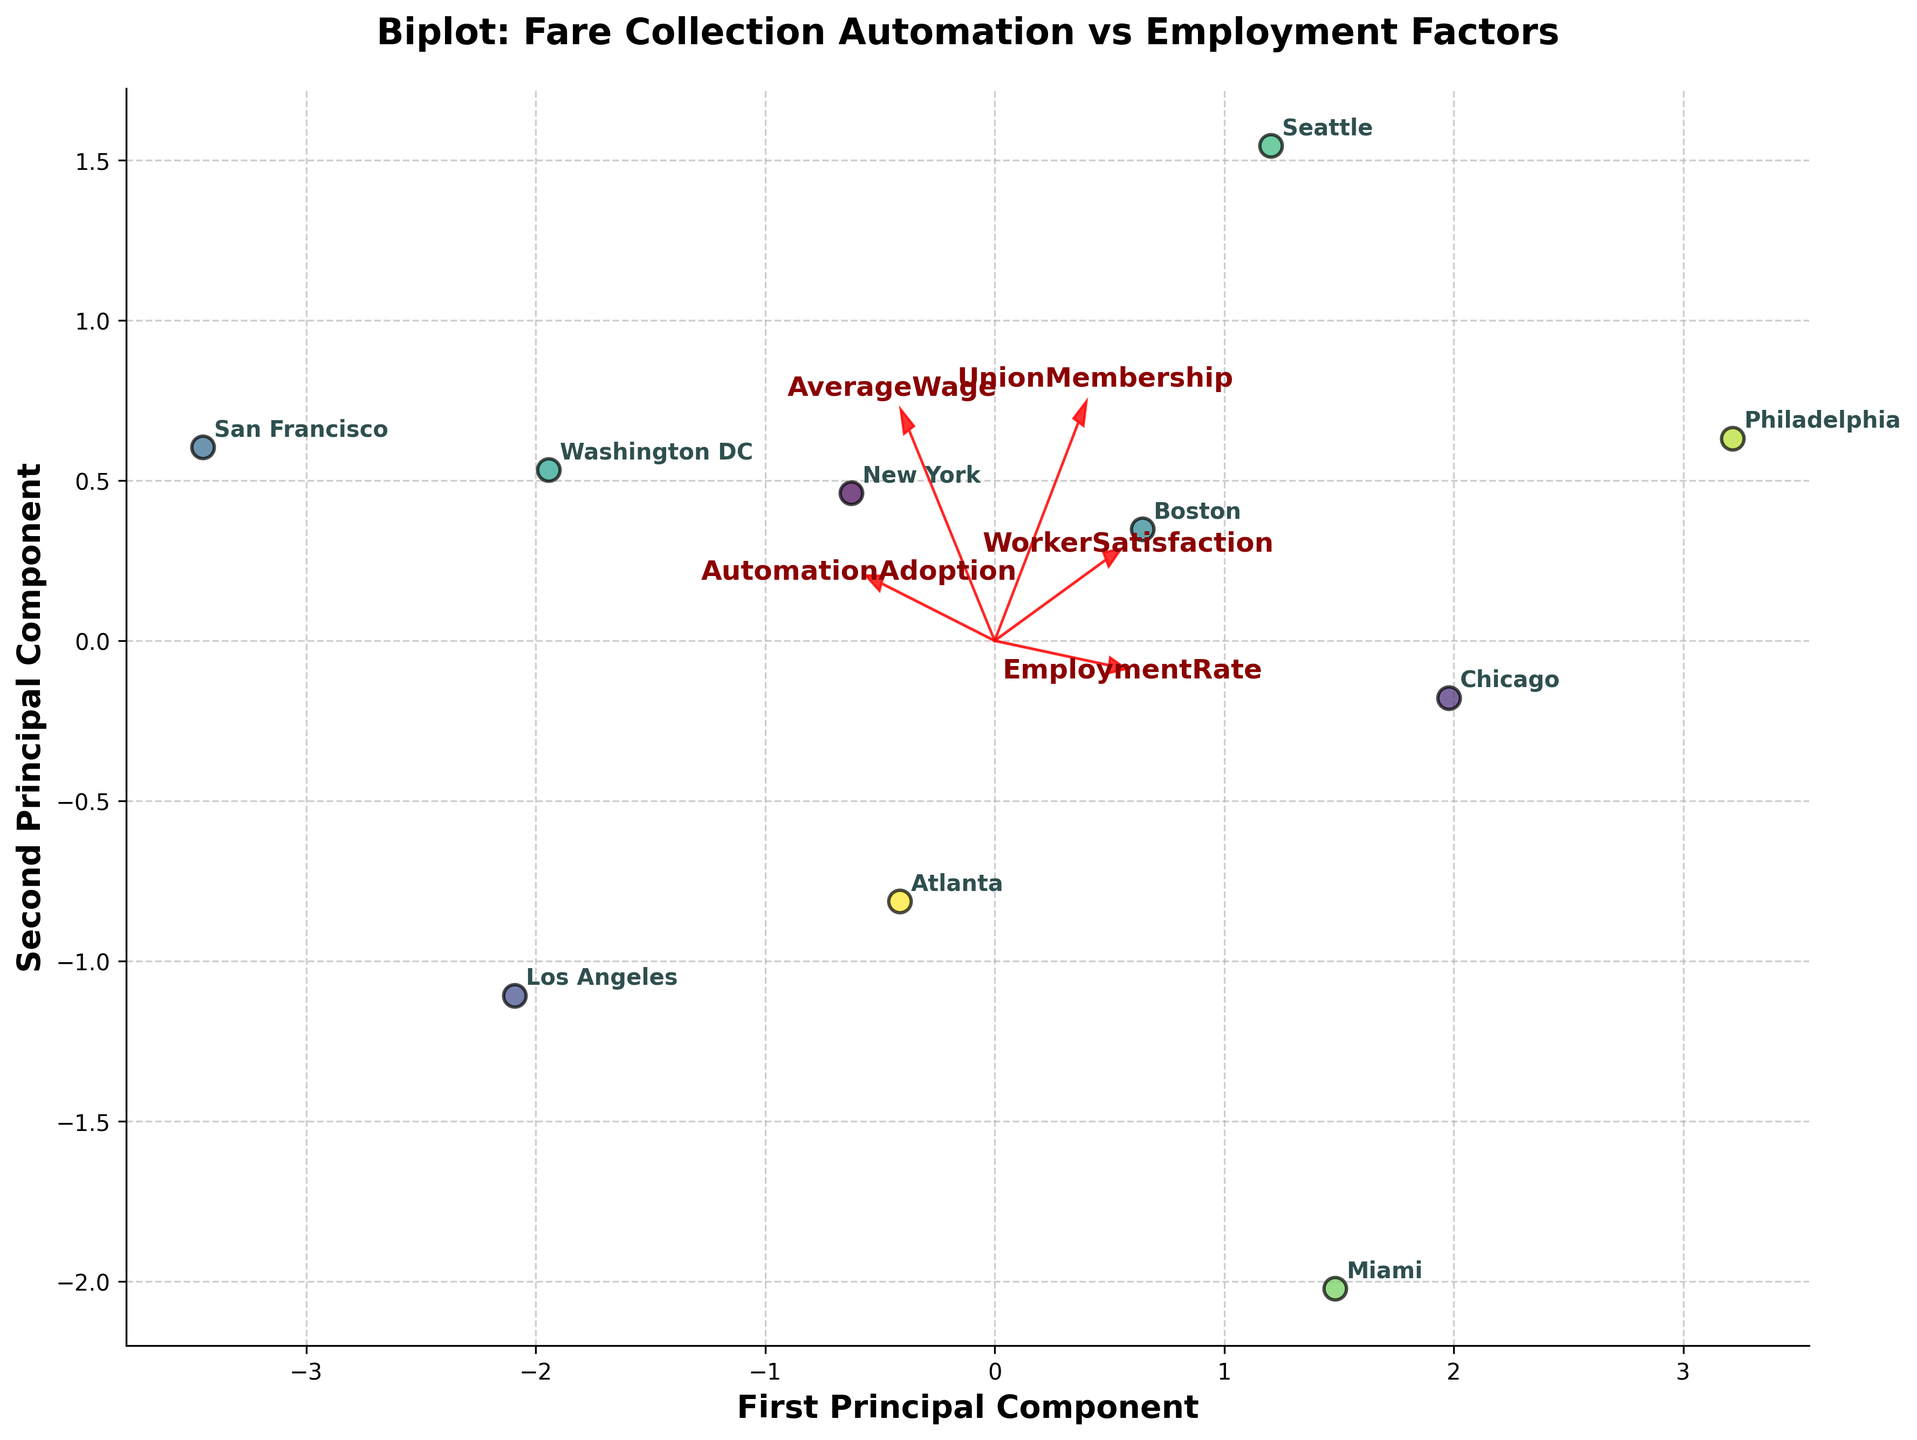How many cities are shown in the figure? To count the number of cities, look at either the number of data points (unique cities) on the biplot or the number of annotations (city names).
Answer: 10 What is the title of the figure? The title of the figure is displayed prominently at the top.
Answer: Biplot: Fare Collection Automation vs Employment Factors Which two variables are the most strongly associated with the first principal component? Look at the direction and length of the arrows representing the variables along the first principal component (X-axis). The longer the arrow in the direction of the component, the stronger the association.
Answer: AutomationAdoption and UnionMembership Which city has the highest automation adoption rate and where is it located on the biplot? Identify the city with the highest value on the AutomationAdoption axis and locate the corresponding data point. Check the city name annotation.
Answer: San Francisco Is there any notable trend between WorkerSatisfaction and EmploymentRate according to the biplot? Observe the direction and angles of the arrows representing WorkerSatisfaction and EmploymentRate. If the arrows point in similar or opposite directions, it indicates a trend. These variables have arrows in similar directions, suggesting a positive relationship.
Answer: Positive relationship What does the arrow for 'AverageWage' indicate about its relationship with the first principal component? The length and direction of the 'AverageWage' arrow relative to the first principal component illustrate its strength and direction of correlation. If the arrow is short and orthogonal, the correlation is weak.
Answer: Weak relationship Which variables seem to be positively correlated with each other? Variables with arrows pointing in the same or similar directions on the biplot are positively correlated. Identify these variables.
Answer: EmploymentRate and WorkerSatisfaction Which city has the highest employment rate, and which principal component direction does it fall under? Identify the city with the highest value on the EmploymentRate arrow and locate its data point along the principal component directions (X or Y).
Answer: Philadelphia, along the second principal component Based on the biplot, which cities cluster closest together indicating similar profiles of analyzed factors? Observe which data points are grouped close to each other. These cities have similar scores on the principal components.
Answer: Chicago, Boston, and Seattle Do any variables appear to negatively correlate with automation adoption? Arrows pointing in nearly opposite directions to AutomationAdoption indicate a negative correlation. Identify these variables.
Answer: WorkerSatisfaction 